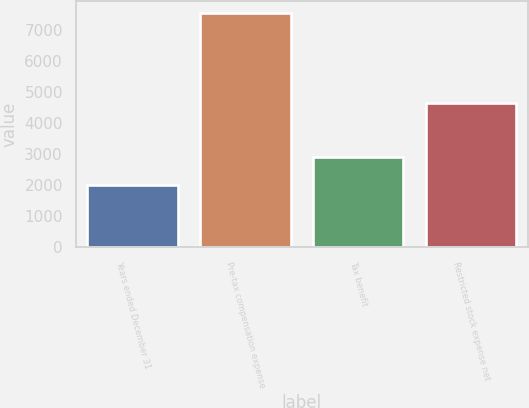Convert chart. <chart><loc_0><loc_0><loc_500><loc_500><bar_chart><fcel>Years ended December 31<fcel>Pre-tax compensation expense<fcel>Tax benefit<fcel>Restricted stock expense net<nl><fcel>2011<fcel>7555<fcel>2909<fcel>4636<nl></chart> 